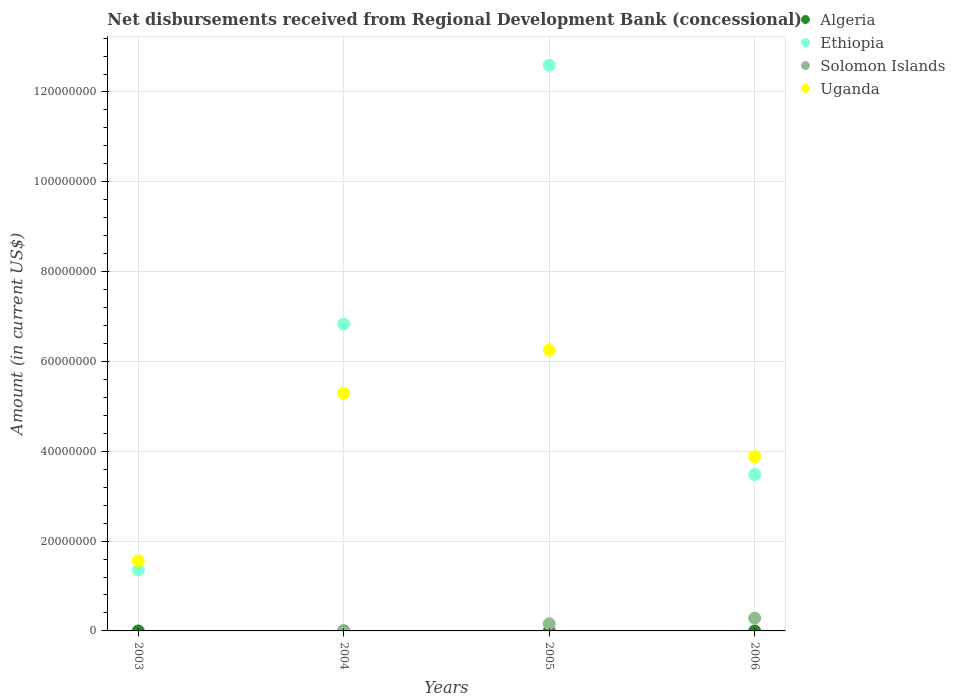What is the amount of disbursements received from Regional Development Bank in Uganda in 2003?
Your answer should be very brief. 1.56e+07. Across all years, what is the maximum amount of disbursements received from Regional Development Bank in Ethiopia?
Provide a succinct answer. 1.26e+08. In which year was the amount of disbursements received from Regional Development Bank in Ethiopia maximum?
Your answer should be very brief. 2005. What is the total amount of disbursements received from Regional Development Bank in Solomon Islands in the graph?
Ensure brevity in your answer.  4.43e+06. What is the difference between the amount of disbursements received from Regional Development Bank in Solomon Islands in 2005 and that in 2006?
Provide a short and direct response. -1.25e+06. What is the difference between the amount of disbursements received from Regional Development Bank in Algeria in 2006 and the amount of disbursements received from Regional Development Bank in Solomon Islands in 2005?
Keep it short and to the point. -1.59e+06. What is the average amount of disbursements received from Regional Development Bank in Solomon Islands per year?
Offer a very short reply. 1.11e+06. In the year 2006, what is the difference between the amount of disbursements received from Regional Development Bank in Solomon Islands and amount of disbursements received from Regional Development Bank in Uganda?
Provide a succinct answer. -3.60e+07. In how many years, is the amount of disbursements received from Regional Development Bank in Ethiopia greater than 68000000 US$?
Make the answer very short. 2. What is the ratio of the amount of disbursements received from Regional Development Bank in Ethiopia in 2004 to that in 2006?
Offer a terse response. 1.96. Is the amount of disbursements received from Regional Development Bank in Uganda in 2003 less than that in 2005?
Make the answer very short. Yes. What is the difference between the highest and the second highest amount of disbursements received from Regional Development Bank in Uganda?
Provide a short and direct response. 9.59e+06. What is the difference between the highest and the lowest amount of disbursements received from Regional Development Bank in Uganda?
Your response must be concise. 4.69e+07. In how many years, is the amount of disbursements received from Regional Development Bank in Ethiopia greater than the average amount of disbursements received from Regional Development Bank in Ethiopia taken over all years?
Give a very brief answer. 2. Is it the case that in every year, the sum of the amount of disbursements received from Regional Development Bank in Ethiopia and amount of disbursements received from Regional Development Bank in Solomon Islands  is greater than the sum of amount of disbursements received from Regional Development Bank in Uganda and amount of disbursements received from Regional Development Bank in Algeria?
Your answer should be very brief. No. Is it the case that in every year, the sum of the amount of disbursements received from Regional Development Bank in Uganda and amount of disbursements received from Regional Development Bank in Solomon Islands  is greater than the amount of disbursements received from Regional Development Bank in Ethiopia?
Your answer should be very brief. No. Does the amount of disbursements received from Regional Development Bank in Uganda monotonically increase over the years?
Your answer should be very brief. No. Is the amount of disbursements received from Regional Development Bank in Algeria strictly greater than the amount of disbursements received from Regional Development Bank in Ethiopia over the years?
Provide a short and direct response. No. How many dotlines are there?
Offer a terse response. 3. How many years are there in the graph?
Your answer should be compact. 4. Are the values on the major ticks of Y-axis written in scientific E-notation?
Your response must be concise. No. Does the graph contain grids?
Provide a short and direct response. Yes. Where does the legend appear in the graph?
Ensure brevity in your answer.  Top right. What is the title of the graph?
Ensure brevity in your answer.  Net disbursements received from Regional Development Bank (concessional). What is the label or title of the X-axis?
Make the answer very short. Years. What is the Amount (in current US$) in Ethiopia in 2003?
Your answer should be compact. 1.36e+07. What is the Amount (in current US$) in Uganda in 2003?
Ensure brevity in your answer.  1.56e+07. What is the Amount (in current US$) in Ethiopia in 2004?
Keep it short and to the point. 6.83e+07. What is the Amount (in current US$) of Solomon Islands in 2004?
Keep it short and to the point. 0. What is the Amount (in current US$) of Uganda in 2004?
Your answer should be very brief. 5.29e+07. What is the Amount (in current US$) in Algeria in 2005?
Your response must be concise. 0. What is the Amount (in current US$) of Ethiopia in 2005?
Your answer should be compact. 1.26e+08. What is the Amount (in current US$) of Solomon Islands in 2005?
Keep it short and to the point. 1.59e+06. What is the Amount (in current US$) of Uganda in 2005?
Your answer should be very brief. 6.25e+07. What is the Amount (in current US$) in Ethiopia in 2006?
Ensure brevity in your answer.  3.48e+07. What is the Amount (in current US$) of Solomon Islands in 2006?
Ensure brevity in your answer.  2.84e+06. What is the Amount (in current US$) in Uganda in 2006?
Give a very brief answer. 3.88e+07. Across all years, what is the maximum Amount (in current US$) of Ethiopia?
Keep it short and to the point. 1.26e+08. Across all years, what is the maximum Amount (in current US$) of Solomon Islands?
Give a very brief answer. 2.84e+06. Across all years, what is the maximum Amount (in current US$) of Uganda?
Give a very brief answer. 6.25e+07. Across all years, what is the minimum Amount (in current US$) of Ethiopia?
Keep it short and to the point. 1.36e+07. Across all years, what is the minimum Amount (in current US$) in Solomon Islands?
Offer a terse response. 0. Across all years, what is the minimum Amount (in current US$) in Uganda?
Ensure brevity in your answer.  1.56e+07. What is the total Amount (in current US$) in Algeria in the graph?
Offer a very short reply. 0. What is the total Amount (in current US$) of Ethiopia in the graph?
Your response must be concise. 2.43e+08. What is the total Amount (in current US$) of Solomon Islands in the graph?
Your answer should be very brief. 4.43e+06. What is the total Amount (in current US$) in Uganda in the graph?
Give a very brief answer. 1.70e+08. What is the difference between the Amount (in current US$) in Ethiopia in 2003 and that in 2004?
Give a very brief answer. -5.47e+07. What is the difference between the Amount (in current US$) in Uganda in 2003 and that in 2004?
Offer a terse response. -3.73e+07. What is the difference between the Amount (in current US$) in Ethiopia in 2003 and that in 2005?
Offer a very short reply. -1.12e+08. What is the difference between the Amount (in current US$) in Uganda in 2003 and that in 2005?
Your response must be concise. -4.69e+07. What is the difference between the Amount (in current US$) in Ethiopia in 2003 and that in 2006?
Your response must be concise. -2.12e+07. What is the difference between the Amount (in current US$) in Uganda in 2003 and that in 2006?
Offer a terse response. -2.32e+07. What is the difference between the Amount (in current US$) in Ethiopia in 2004 and that in 2005?
Provide a succinct answer. -5.76e+07. What is the difference between the Amount (in current US$) in Uganda in 2004 and that in 2005?
Provide a succinct answer. -9.59e+06. What is the difference between the Amount (in current US$) of Ethiopia in 2004 and that in 2006?
Give a very brief answer. 3.35e+07. What is the difference between the Amount (in current US$) of Uganda in 2004 and that in 2006?
Your answer should be very brief. 1.41e+07. What is the difference between the Amount (in current US$) in Ethiopia in 2005 and that in 2006?
Offer a very short reply. 9.11e+07. What is the difference between the Amount (in current US$) in Solomon Islands in 2005 and that in 2006?
Offer a terse response. -1.25e+06. What is the difference between the Amount (in current US$) in Uganda in 2005 and that in 2006?
Your answer should be very brief. 2.37e+07. What is the difference between the Amount (in current US$) of Ethiopia in 2003 and the Amount (in current US$) of Uganda in 2004?
Give a very brief answer. -3.93e+07. What is the difference between the Amount (in current US$) in Ethiopia in 2003 and the Amount (in current US$) in Solomon Islands in 2005?
Offer a terse response. 1.20e+07. What is the difference between the Amount (in current US$) in Ethiopia in 2003 and the Amount (in current US$) in Uganda in 2005?
Offer a very short reply. -4.89e+07. What is the difference between the Amount (in current US$) in Ethiopia in 2003 and the Amount (in current US$) in Solomon Islands in 2006?
Give a very brief answer. 1.08e+07. What is the difference between the Amount (in current US$) of Ethiopia in 2003 and the Amount (in current US$) of Uganda in 2006?
Provide a short and direct response. -2.52e+07. What is the difference between the Amount (in current US$) in Ethiopia in 2004 and the Amount (in current US$) in Solomon Islands in 2005?
Your answer should be compact. 6.67e+07. What is the difference between the Amount (in current US$) in Ethiopia in 2004 and the Amount (in current US$) in Uganda in 2005?
Offer a terse response. 5.82e+06. What is the difference between the Amount (in current US$) in Ethiopia in 2004 and the Amount (in current US$) in Solomon Islands in 2006?
Your answer should be compact. 6.55e+07. What is the difference between the Amount (in current US$) in Ethiopia in 2004 and the Amount (in current US$) in Uganda in 2006?
Offer a terse response. 2.95e+07. What is the difference between the Amount (in current US$) of Ethiopia in 2005 and the Amount (in current US$) of Solomon Islands in 2006?
Make the answer very short. 1.23e+08. What is the difference between the Amount (in current US$) of Ethiopia in 2005 and the Amount (in current US$) of Uganda in 2006?
Give a very brief answer. 8.71e+07. What is the difference between the Amount (in current US$) in Solomon Islands in 2005 and the Amount (in current US$) in Uganda in 2006?
Provide a short and direct response. -3.72e+07. What is the average Amount (in current US$) in Algeria per year?
Offer a terse response. 0. What is the average Amount (in current US$) in Ethiopia per year?
Ensure brevity in your answer.  6.07e+07. What is the average Amount (in current US$) of Solomon Islands per year?
Your answer should be compact. 1.11e+06. What is the average Amount (in current US$) in Uganda per year?
Keep it short and to the point. 4.25e+07. In the year 2003, what is the difference between the Amount (in current US$) of Ethiopia and Amount (in current US$) of Uganda?
Ensure brevity in your answer.  -1.98e+06. In the year 2004, what is the difference between the Amount (in current US$) of Ethiopia and Amount (in current US$) of Uganda?
Offer a very short reply. 1.54e+07. In the year 2005, what is the difference between the Amount (in current US$) in Ethiopia and Amount (in current US$) in Solomon Islands?
Keep it short and to the point. 1.24e+08. In the year 2005, what is the difference between the Amount (in current US$) of Ethiopia and Amount (in current US$) of Uganda?
Your response must be concise. 6.34e+07. In the year 2005, what is the difference between the Amount (in current US$) in Solomon Islands and Amount (in current US$) in Uganda?
Ensure brevity in your answer.  -6.09e+07. In the year 2006, what is the difference between the Amount (in current US$) of Ethiopia and Amount (in current US$) of Solomon Islands?
Give a very brief answer. 3.20e+07. In the year 2006, what is the difference between the Amount (in current US$) in Ethiopia and Amount (in current US$) in Uganda?
Offer a very short reply. -3.98e+06. In the year 2006, what is the difference between the Amount (in current US$) of Solomon Islands and Amount (in current US$) of Uganda?
Offer a very short reply. -3.60e+07. What is the ratio of the Amount (in current US$) of Ethiopia in 2003 to that in 2004?
Make the answer very short. 0.2. What is the ratio of the Amount (in current US$) in Uganda in 2003 to that in 2004?
Ensure brevity in your answer.  0.29. What is the ratio of the Amount (in current US$) in Ethiopia in 2003 to that in 2005?
Offer a terse response. 0.11. What is the ratio of the Amount (in current US$) in Uganda in 2003 to that in 2005?
Offer a terse response. 0.25. What is the ratio of the Amount (in current US$) of Ethiopia in 2003 to that in 2006?
Offer a terse response. 0.39. What is the ratio of the Amount (in current US$) of Uganda in 2003 to that in 2006?
Your response must be concise. 0.4. What is the ratio of the Amount (in current US$) of Ethiopia in 2004 to that in 2005?
Give a very brief answer. 0.54. What is the ratio of the Amount (in current US$) in Uganda in 2004 to that in 2005?
Your response must be concise. 0.85. What is the ratio of the Amount (in current US$) of Ethiopia in 2004 to that in 2006?
Keep it short and to the point. 1.96. What is the ratio of the Amount (in current US$) of Uganda in 2004 to that in 2006?
Your answer should be compact. 1.36. What is the ratio of the Amount (in current US$) in Ethiopia in 2005 to that in 2006?
Give a very brief answer. 3.62. What is the ratio of the Amount (in current US$) of Solomon Islands in 2005 to that in 2006?
Provide a short and direct response. 0.56. What is the ratio of the Amount (in current US$) in Uganda in 2005 to that in 2006?
Offer a terse response. 1.61. What is the difference between the highest and the second highest Amount (in current US$) of Ethiopia?
Offer a terse response. 5.76e+07. What is the difference between the highest and the second highest Amount (in current US$) in Uganda?
Provide a succinct answer. 9.59e+06. What is the difference between the highest and the lowest Amount (in current US$) in Ethiopia?
Make the answer very short. 1.12e+08. What is the difference between the highest and the lowest Amount (in current US$) of Solomon Islands?
Offer a very short reply. 2.84e+06. What is the difference between the highest and the lowest Amount (in current US$) of Uganda?
Ensure brevity in your answer.  4.69e+07. 